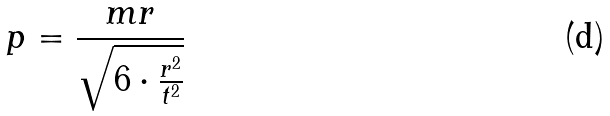Convert formula to latex. <formula><loc_0><loc_0><loc_500><loc_500>p = \frac { m r } { \sqrt { 6 \cdot \frac { r ^ { 2 } } { t ^ { 2 } } } }</formula> 